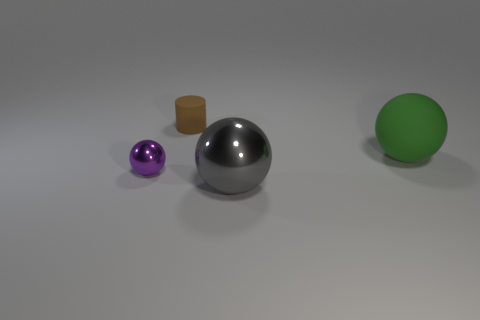Add 2 green rubber cubes. How many objects exist? 6 Subtract all cylinders. How many objects are left? 3 Subtract all big gray metallic objects. Subtract all tiny purple metallic balls. How many objects are left? 2 Add 1 brown cylinders. How many brown cylinders are left? 2 Add 1 gray rubber cubes. How many gray rubber cubes exist? 1 Subtract 0 purple blocks. How many objects are left? 4 